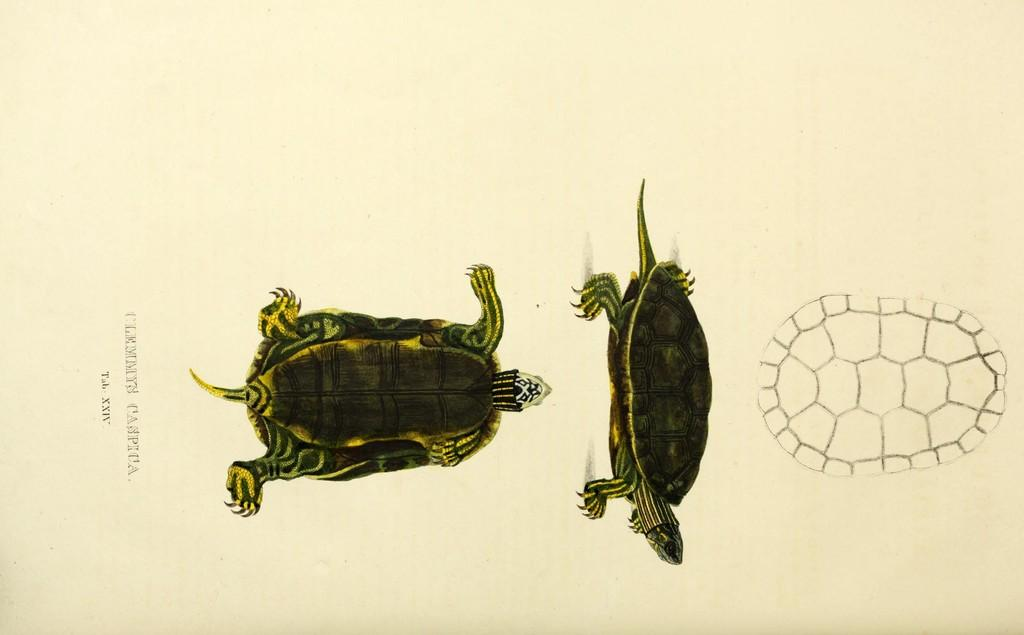What type of image is being described? The image is a drawing. What animals are depicted in the drawing? There are tortoises in the drawing. Is there any text present in the drawing? Yes, there is writing on the left side of the drawing. How many dinosaurs are jumping on the tramp in the image? There are no dinosaurs or tramps present in the image; it features a drawing of tortoises and writing. 